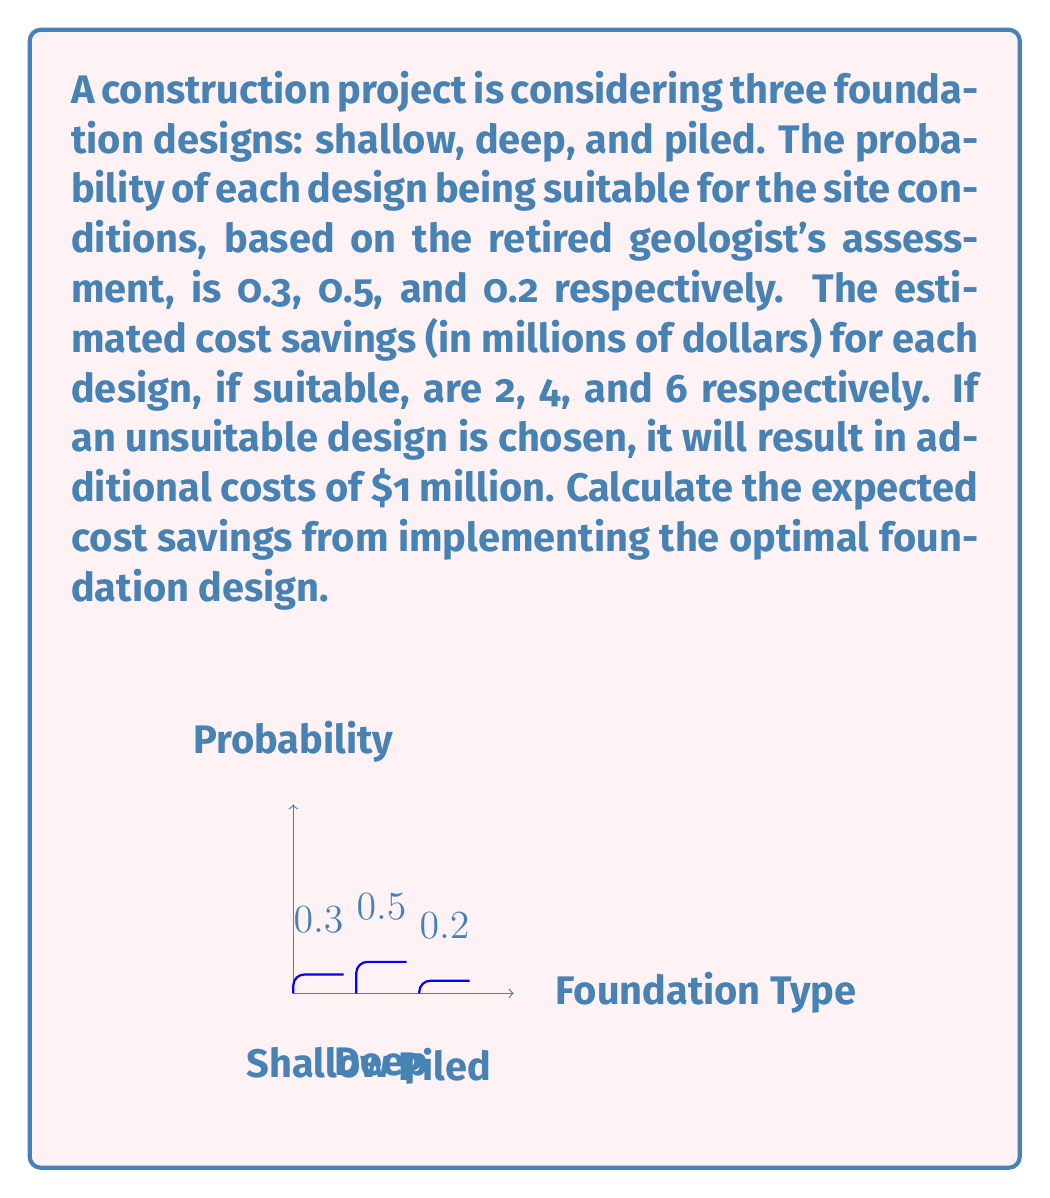Solve this math problem. Let's approach this step-by-step:

1) First, we need to calculate the expected value of cost savings for each design:

   For shallow foundation:
   $E(\text{shallow}) = 0.3 \times 2 + 0.7 \times (-1) = 0.6 - 0.7 = -0.1$ million

   For deep foundation:
   $E(\text{deep}) = 0.5 \times 4 + 0.5 \times (-1) = 2 - 0.5 = 1.5$ million

   For piled foundation:
   $E(\text{piled}) = 0.2 \times 6 + 0.8 \times (-1) = 1.2 - 0.8 = 0.4$ million

2) The optimal design is the one with the highest expected value, which is the deep foundation with an expected cost saving of $1.5 million.

3) Therefore, the expected cost savings from implementing the optimal foundation design is $1.5 million.
Answer: $1.5 million 